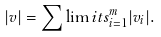<formula> <loc_0><loc_0><loc_500><loc_500>| v | = \sum \lim i t s _ { i = 1 } ^ { m } | v _ { i } | .</formula> 